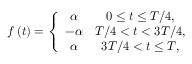<formula> <loc_0><loc_0><loc_500><loc_500>\begin{array} { r } { f \left ( t \right ) = \left \{ \begin{array} { c c } { \alpha } & { 0 \leq t \leq T / 4 , } \\ { - \alpha } & { T / 4 < t < 3 T / 4 , } \\ { \alpha } & { 3 T / 4 < t \leq T , } \end{array} } \end{array}</formula> 